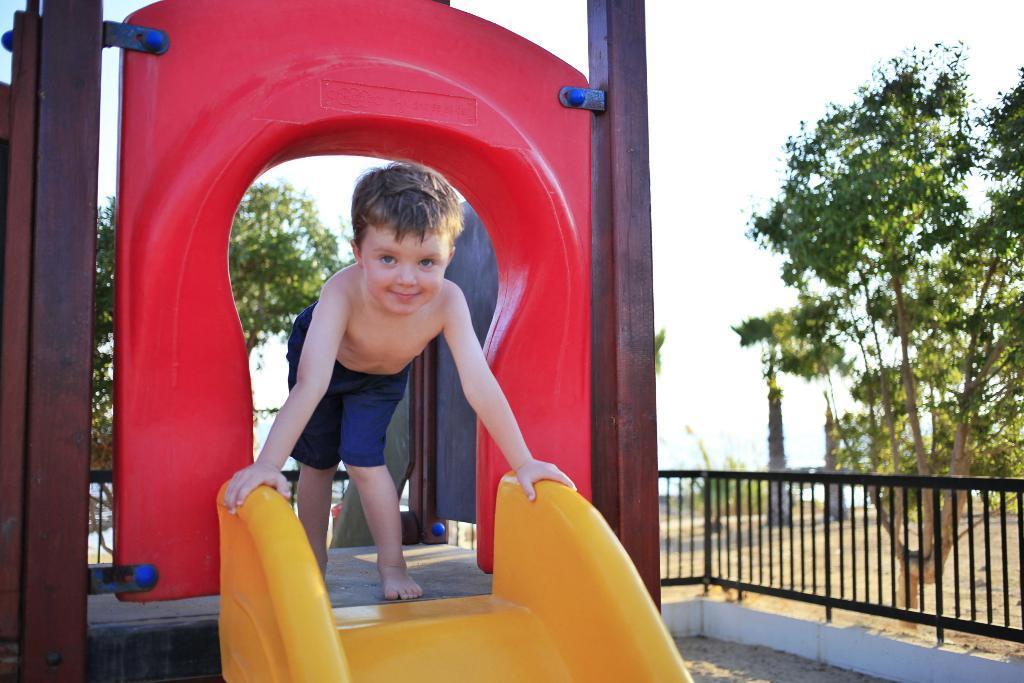Could you give a brief overview of what you see in this image? In this image I can see a park's ride in the front and on it I can see a boy, I can see he is wearing shorts. In the background I can see railing and number of trees. 